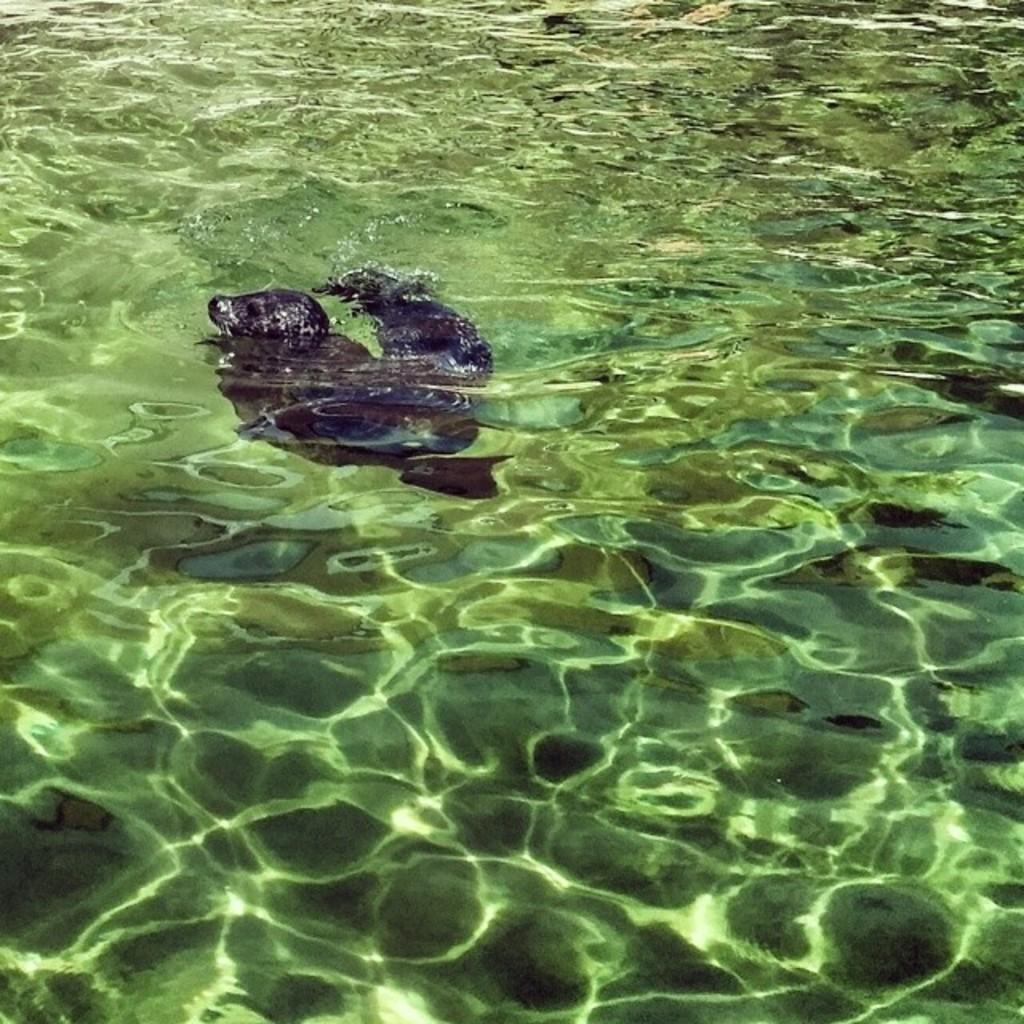Could you give a brief overview of what you see in this image? In this picture we can see water, there is something present in the water. 